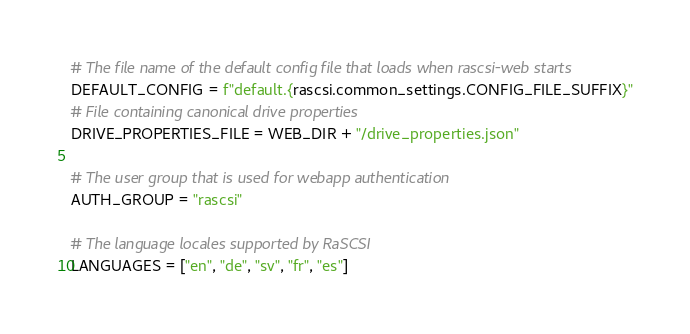Convert code to text. <code><loc_0><loc_0><loc_500><loc_500><_Python_># The file name of the default config file that loads when rascsi-web starts
DEFAULT_CONFIG = f"default.{rascsi.common_settings.CONFIG_FILE_SUFFIX}"
# File containing canonical drive properties
DRIVE_PROPERTIES_FILE = WEB_DIR + "/drive_properties.json"

# The user group that is used for webapp authentication
AUTH_GROUP = "rascsi"

# The language locales supported by RaSCSI
LANGUAGES = ["en", "de", "sv", "fr", "es"]
</code> 